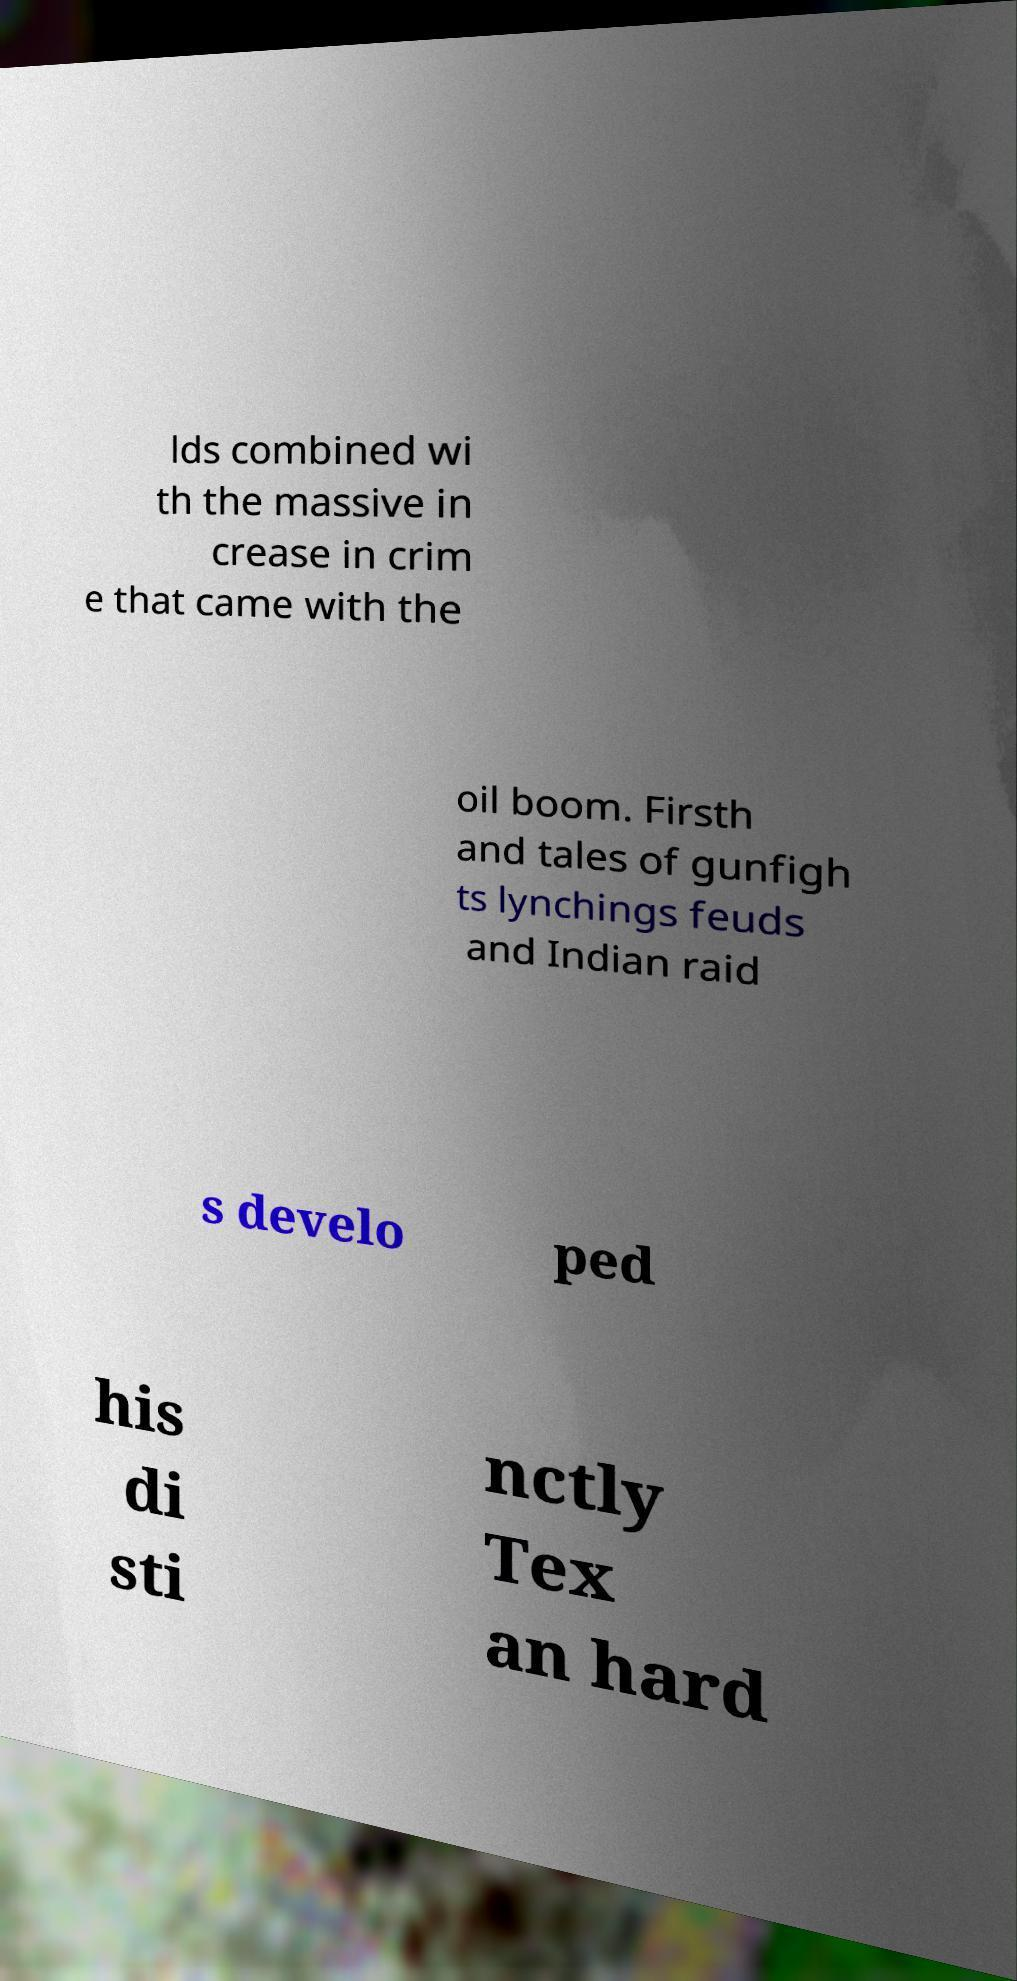Can you read and provide the text displayed in the image?This photo seems to have some interesting text. Can you extract and type it out for me? lds combined wi th the massive in crease in crim e that came with the oil boom. Firsth and tales of gunfigh ts lynchings feuds and Indian raid s develo ped his di sti nctly Tex an hard 